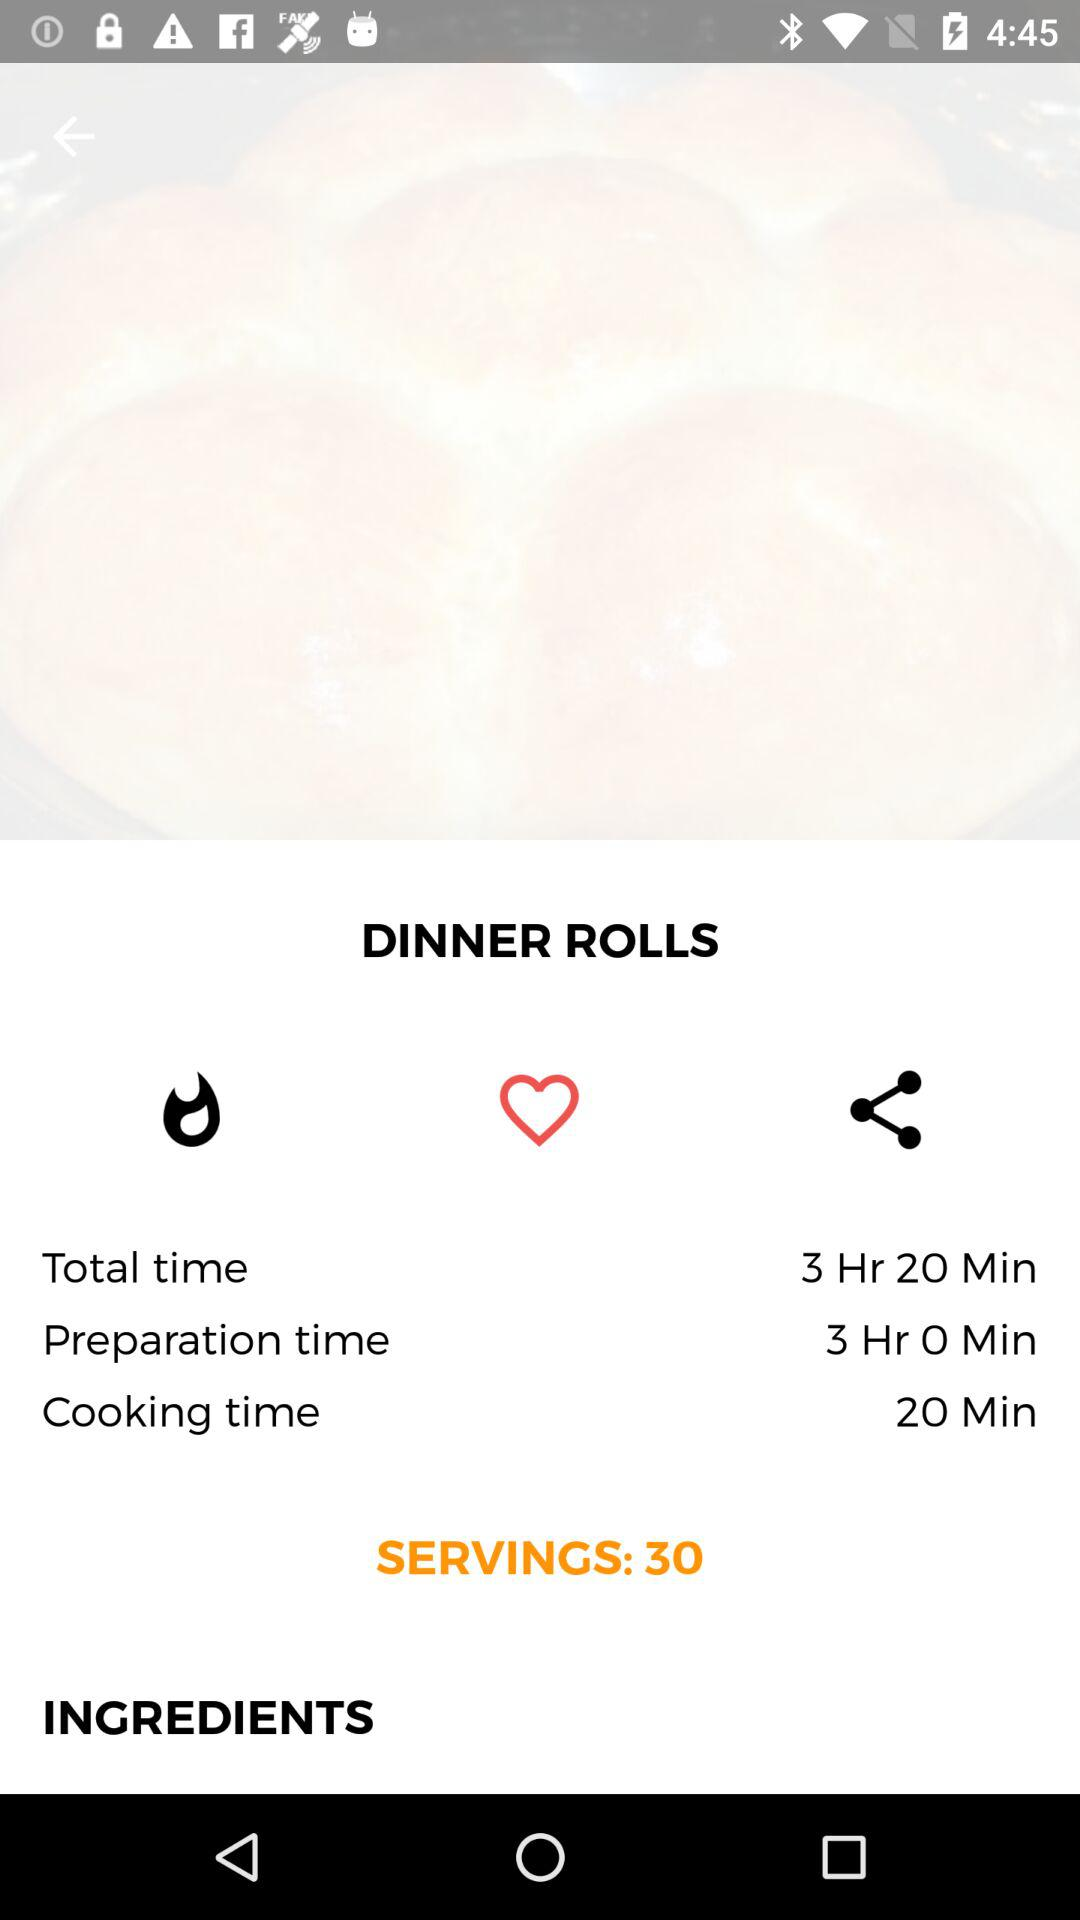What is the dish name? The dish name is dinner rolls. 